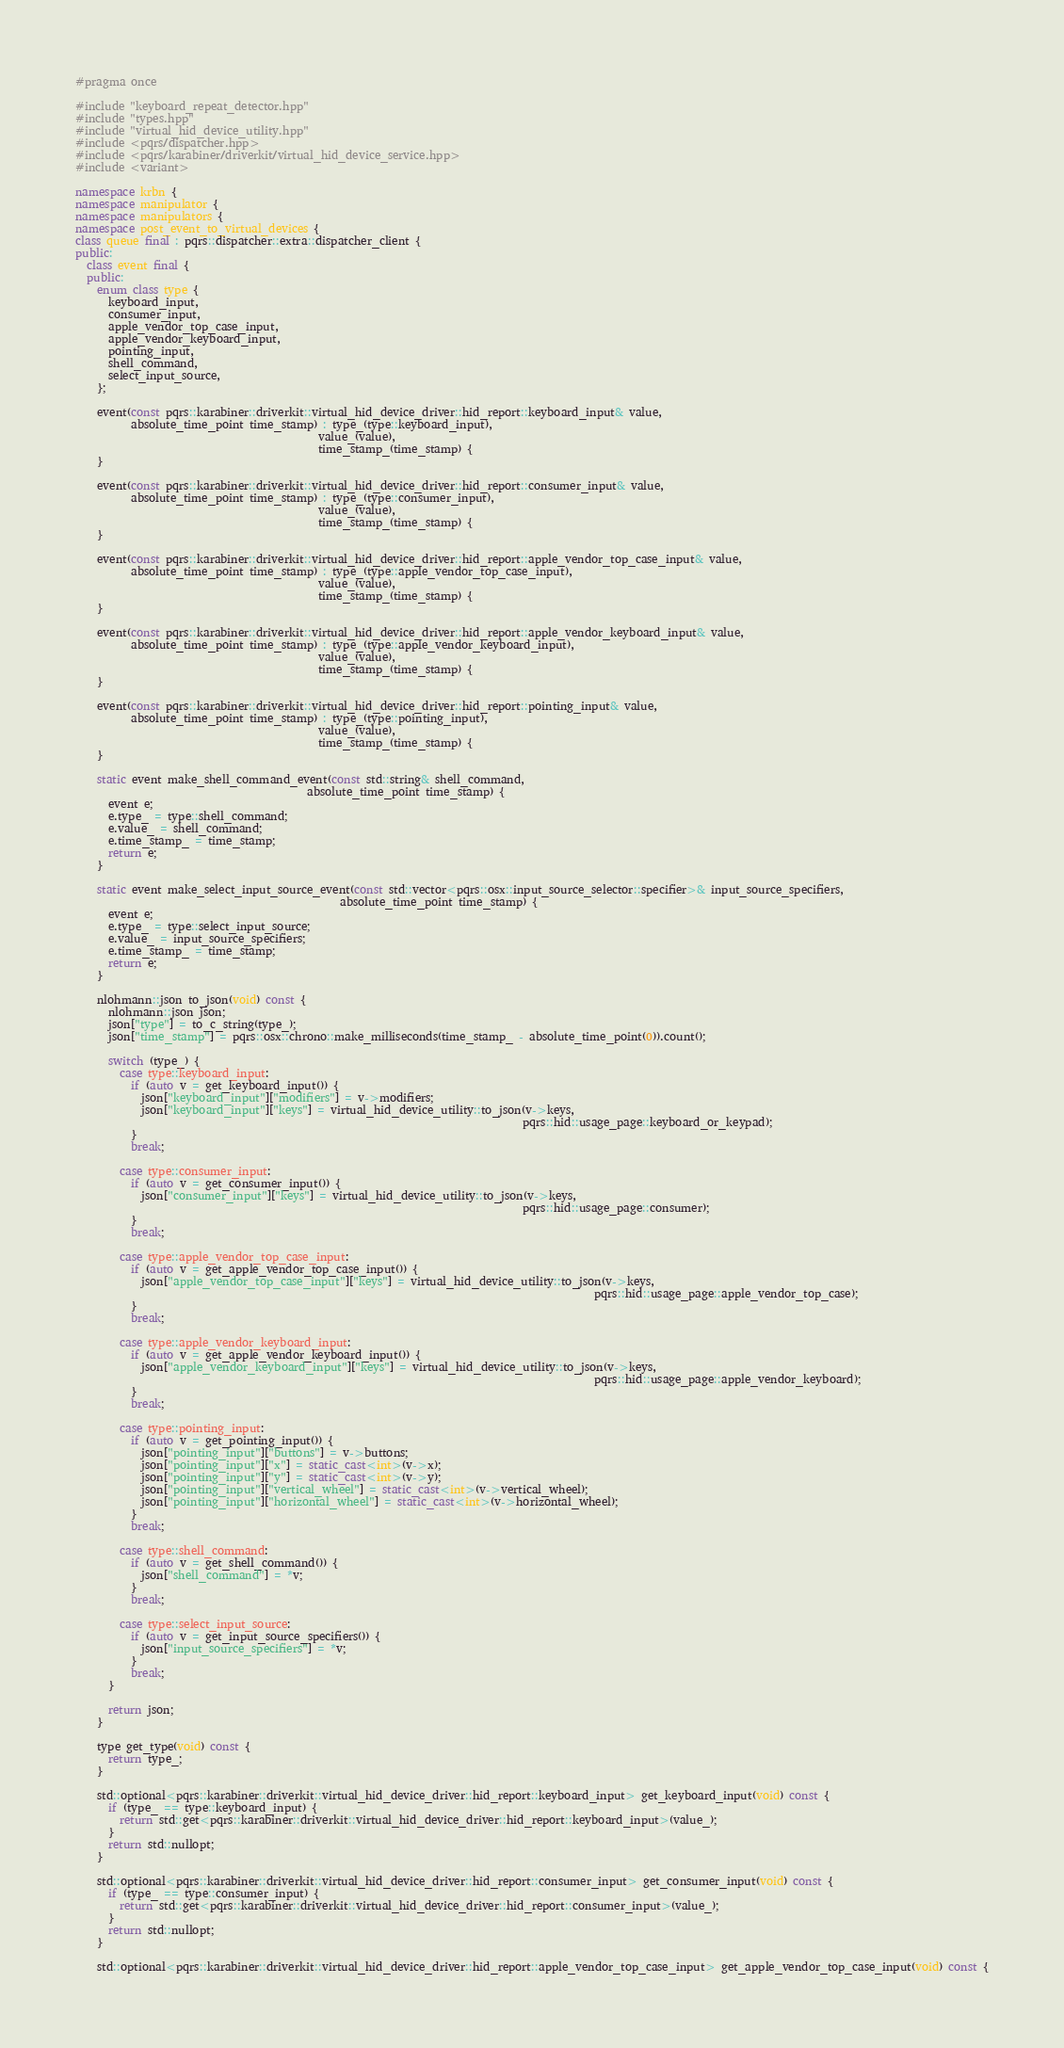<code> <loc_0><loc_0><loc_500><loc_500><_C++_>#pragma once

#include "keyboard_repeat_detector.hpp"
#include "types.hpp"
#include "virtual_hid_device_utility.hpp"
#include <pqrs/dispatcher.hpp>
#include <pqrs/karabiner/driverkit/virtual_hid_device_service.hpp>
#include <variant>

namespace krbn {
namespace manipulator {
namespace manipulators {
namespace post_event_to_virtual_devices {
class queue final : pqrs::dispatcher::extra::dispatcher_client {
public:
  class event final {
  public:
    enum class type {
      keyboard_input,
      consumer_input,
      apple_vendor_top_case_input,
      apple_vendor_keyboard_input,
      pointing_input,
      shell_command,
      select_input_source,
    };

    event(const pqrs::karabiner::driverkit::virtual_hid_device_driver::hid_report::keyboard_input& value,
          absolute_time_point time_stamp) : type_(type::keyboard_input),
                                            value_(value),
                                            time_stamp_(time_stamp) {
    }

    event(const pqrs::karabiner::driverkit::virtual_hid_device_driver::hid_report::consumer_input& value,
          absolute_time_point time_stamp) : type_(type::consumer_input),
                                            value_(value),
                                            time_stamp_(time_stamp) {
    }

    event(const pqrs::karabiner::driverkit::virtual_hid_device_driver::hid_report::apple_vendor_top_case_input& value,
          absolute_time_point time_stamp) : type_(type::apple_vendor_top_case_input),
                                            value_(value),
                                            time_stamp_(time_stamp) {
    }

    event(const pqrs::karabiner::driverkit::virtual_hid_device_driver::hid_report::apple_vendor_keyboard_input& value,
          absolute_time_point time_stamp) : type_(type::apple_vendor_keyboard_input),
                                            value_(value),
                                            time_stamp_(time_stamp) {
    }

    event(const pqrs::karabiner::driverkit::virtual_hid_device_driver::hid_report::pointing_input& value,
          absolute_time_point time_stamp) : type_(type::pointing_input),
                                            value_(value),
                                            time_stamp_(time_stamp) {
    }

    static event make_shell_command_event(const std::string& shell_command,
                                          absolute_time_point time_stamp) {
      event e;
      e.type_ = type::shell_command;
      e.value_ = shell_command;
      e.time_stamp_ = time_stamp;
      return e;
    }

    static event make_select_input_source_event(const std::vector<pqrs::osx::input_source_selector::specifier>& input_source_specifiers,
                                                absolute_time_point time_stamp) {
      event e;
      e.type_ = type::select_input_source;
      e.value_ = input_source_specifiers;
      e.time_stamp_ = time_stamp;
      return e;
    }

    nlohmann::json to_json(void) const {
      nlohmann::json json;
      json["type"] = to_c_string(type_);
      json["time_stamp"] = pqrs::osx::chrono::make_milliseconds(time_stamp_ - absolute_time_point(0)).count();

      switch (type_) {
        case type::keyboard_input:
          if (auto v = get_keyboard_input()) {
            json["keyboard_input"]["modifiers"] = v->modifiers;
            json["keyboard_input"]["keys"] = virtual_hid_device_utility::to_json(v->keys,
                                                                                 pqrs::hid::usage_page::keyboard_or_keypad);
          }
          break;

        case type::consumer_input:
          if (auto v = get_consumer_input()) {
            json["consumer_input"]["keys"] = virtual_hid_device_utility::to_json(v->keys,
                                                                                 pqrs::hid::usage_page::consumer);
          }
          break;

        case type::apple_vendor_top_case_input:
          if (auto v = get_apple_vendor_top_case_input()) {
            json["apple_vendor_top_case_input"]["keys"] = virtual_hid_device_utility::to_json(v->keys,
                                                                                              pqrs::hid::usage_page::apple_vendor_top_case);
          }
          break;

        case type::apple_vendor_keyboard_input:
          if (auto v = get_apple_vendor_keyboard_input()) {
            json["apple_vendor_keyboard_input"]["keys"] = virtual_hid_device_utility::to_json(v->keys,
                                                                                              pqrs::hid::usage_page::apple_vendor_keyboard);
          }
          break;

        case type::pointing_input:
          if (auto v = get_pointing_input()) {
            json["pointing_input"]["buttons"] = v->buttons;
            json["pointing_input"]["x"] = static_cast<int>(v->x);
            json["pointing_input"]["y"] = static_cast<int>(v->y);
            json["pointing_input"]["vertical_wheel"] = static_cast<int>(v->vertical_wheel);
            json["pointing_input"]["horizontal_wheel"] = static_cast<int>(v->horizontal_wheel);
          }
          break;

        case type::shell_command:
          if (auto v = get_shell_command()) {
            json["shell_command"] = *v;
          }
          break;

        case type::select_input_source:
          if (auto v = get_input_source_specifiers()) {
            json["input_source_specifiers"] = *v;
          }
          break;
      }

      return json;
    }

    type get_type(void) const {
      return type_;
    }

    std::optional<pqrs::karabiner::driverkit::virtual_hid_device_driver::hid_report::keyboard_input> get_keyboard_input(void) const {
      if (type_ == type::keyboard_input) {
        return std::get<pqrs::karabiner::driverkit::virtual_hid_device_driver::hid_report::keyboard_input>(value_);
      }
      return std::nullopt;
    }

    std::optional<pqrs::karabiner::driverkit::virtual_hid_device_driver::hid_report::consumer_input> get_consumer_input(void) const {
      if (type_ == type::consumer_input) {
        return std::get<pqrs::karabiner::driverkit::virtual_hid_device_driver::hid_report::consumer_input>(value_);
      }
      return std::nullopt;
    }

    std::optional<pqrs::karabiner::driverkit::virtual_hid_device_driver::hid_report::apple_vendor_top_case_input> get_apple_vendor_top_case_input(void) const {</code> 